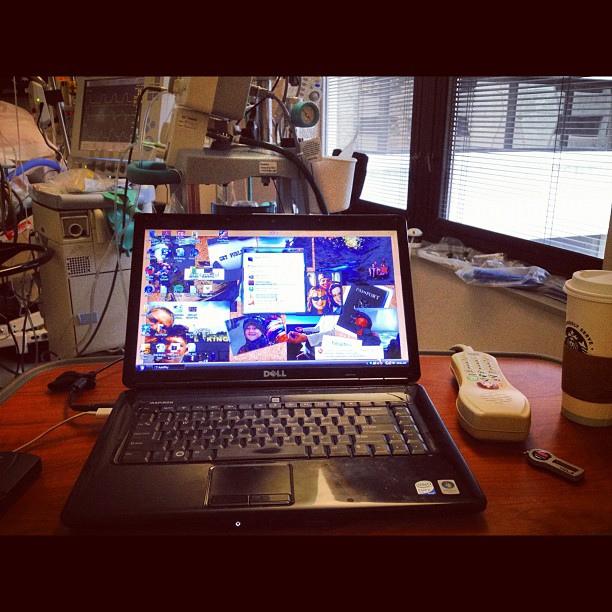How many beverages are on the table?
Answer briefly. 1. What brand computer is this?
Give a very brief answer. Dell. Where is the coffee cup?
Concise answer only. Right. What color is the computer?
Keep it brief. Black. 